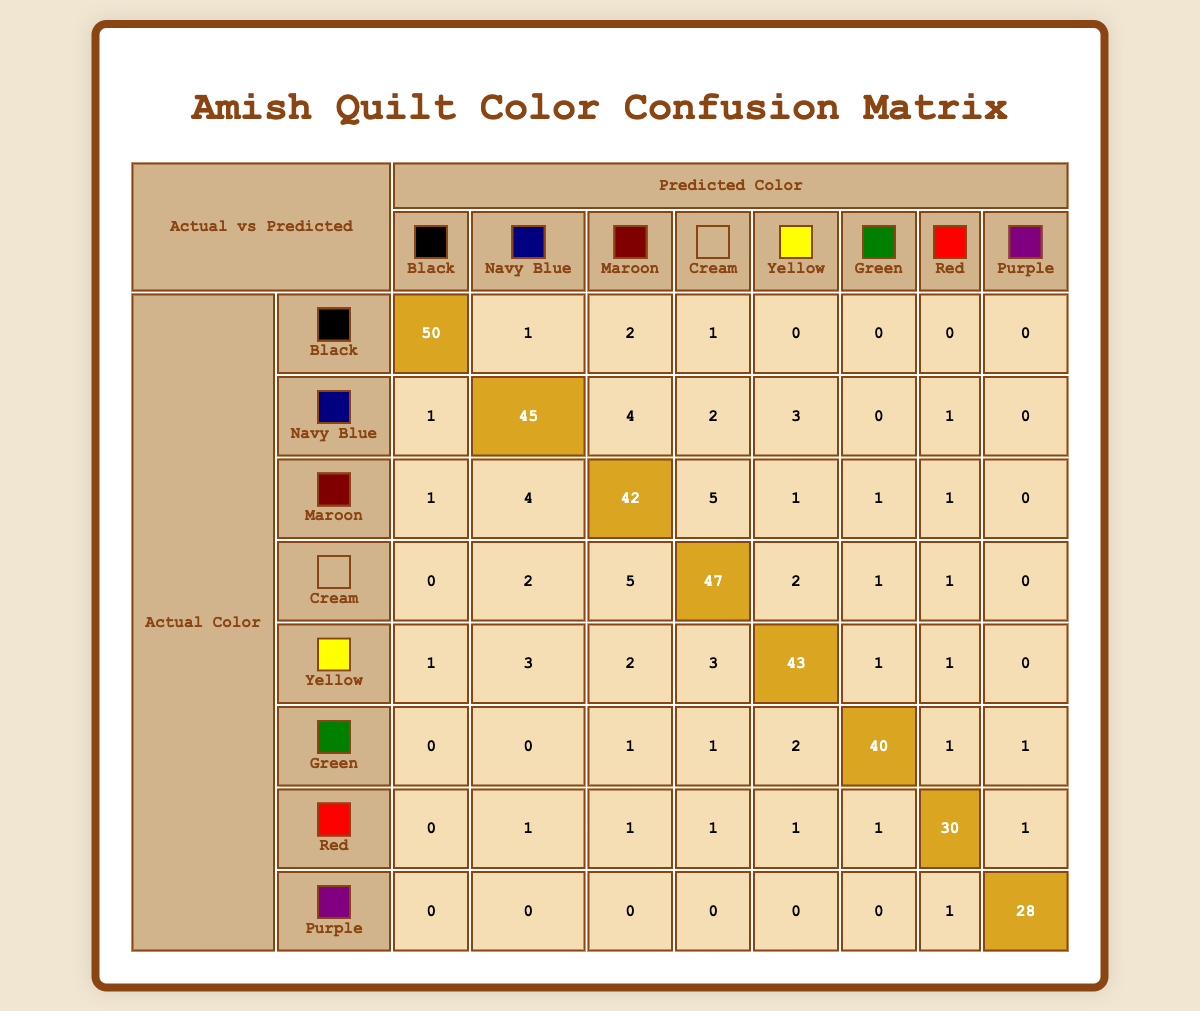What is the number of times "Black" was predicted as "Black"? According to the table, the intersection of the "Black" row and "Black" column shows the value 50. This indicates that "Black" was correctly predicted 50 times.
Answer: 50 What is the total number of times "Maroon" was incorrectly predicted as another color? To determine this, we need to sum all the values in the "Maroon" row except for the "Maroon" column. The incorrect predictions are 1 (Black) + 4 (Navy Blue) + 5 (Cream) + 1 (Yellow) + 1 (Green) + 1 (Red) + 0 (Purple) = 13.
Answer: 13 Is "Red" predicted more often as "Red" than "Green" is predicted as "Green"? The table shows that "Red" was predicted as "Red" 30 times, while "Green" was predicted as "Green" 40 times. Since 30 is less than 40, the answer is no.
Answer: No What is the percentage of correct predictions for the color "Cream"? The correct predictions for "Cream" is 47 (the value at the intersection of the "Cream" row and "Cream" column). To calculate the total predictions for "Cream," we sum all the values in the "Cream" row: 0 + 2 + 5 + 47 + 2 + 1 + 1 + 0 = 58. The percentage of correct predictions is (47/58) * 100 ≈ 81.03%.
Answer: 81.03% How many colors were predicted at least once as "Purple"? By examining the "Purple" column, we see predictions of 1 (Red) and 28 (Purple). Therefore, the total number of colors predicted at least once as "Purple" is 2.
Answer: 2 What is the difference in the number of correct predictions between "Yellow" and "Navy Blue"? The correct predictions for "Yellow" is 43, and for "Navy Blue", it is 45. The difference is 45 - 43 = 2. Hence, Navy Blue has 2 more correct predictions than Yellow.
Answer: 2 Was "Navy Blue" confused with "Black" more often than "Red" was confused with "Navy Blue"? Looking at the confusion matrix, "Navy Blue" was predicted as "Black" 1 time and "Red" was predicted as "Navy Blue" 1 time. Therefore, both values are equal, which means they are confused equally often.
Answer: No Which color had the highest number of misclassifications? To find this, we check all the misclassification values. "Maroon" had a total of 13 misclassifications, while other colors had lesser misclassifications. Thus, "Maroon" had the highest number of misclassifications.
Answer: Maroon 